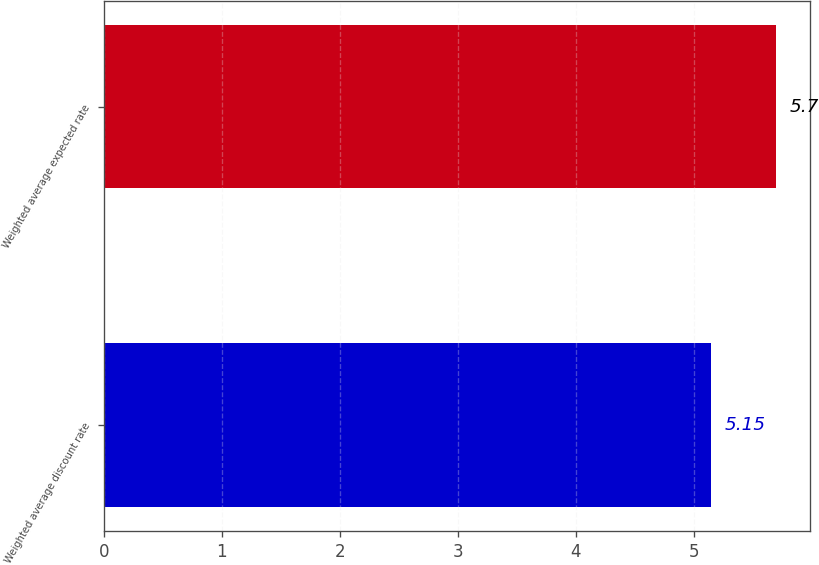Convert chart to OTSL. <chart><loc_0><loc_0><loc_500><loc_500><bar_chart><fcel>Weighted average discount rate<fcel>Weighted average expected rate<nl><fcel>5.15<fcel>5.7<nl></chart> 